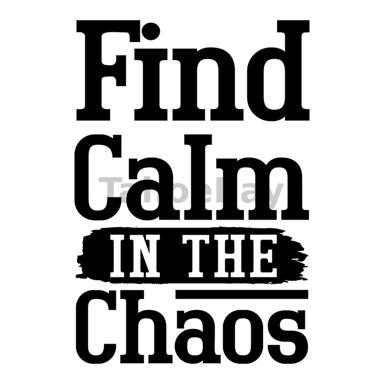Analyze the font and design used on this image. How do they contribute to the message? The font used in the image, with its bold and clear letters, emphasizes a strong, commanding presence, which aligns with the decisive nature of the message 'Find Calm IN THE Chaos.' The brushstroke-like effect on the word 'CHAOS' visually portrays the concept of disorder, contrasting dramatically with the orderly and crisp appearance of the other words. This design choice not only draws attention to the word 'chaos' but also visually represents the juxtaposition of calmness within disorder, enhancing the overall impact of the message by using typography to symbolize the themes discussed. 